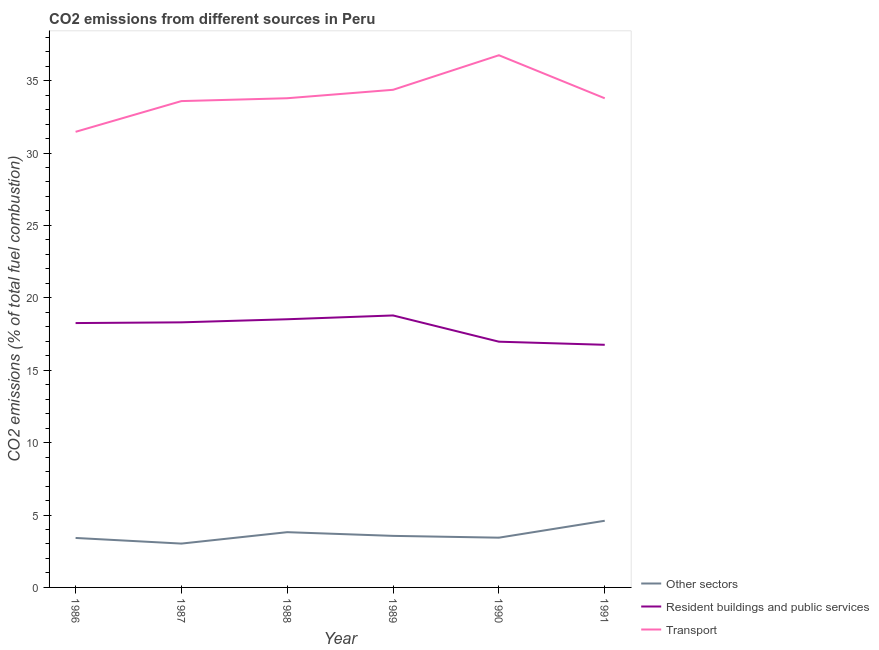Is the number of lines equal to the number of legend labels?
Give a very brief answer. Yes. What is the percentage of co2 emissions from other sectors in 1991?
Ensure brevity in your answer.  4.6. Across all years, what is the maximum percentage of co2 emissions from other sectors?
Offer a terse response. 4.6. Across all years, what is the minimum percentage of co2 emissions from transport?
Ensure brevity in your answer.  31.46. In which year was the percentage of co2 emissions from transport maximum?
Your answer should be compact. 1990. What is the total percentage of co2 emissions from other sectors in the graph?
Provide a short and direct response. 21.86. What is the difference between the percentage of co2 emissions from other sectors in 1989 and that in 1991?
Your response must be concise. -1.04. What is the difference between the percentage of co2 emissions from resident buildings and public services in 1989 and the percentage of co2 emissions from transport in 1991?
Provide a short and direct response. -15. What is the average percentage of co2 emissions from transport per year?
Offer a terse response. 33.95. In the year 1990, what is the difference between the percentage of co2 emissions from resident buildings and public services and percentage of co2 emissions from other sectors?
Give a very brief answer. 13.53. What is the ratio of the percentage of co2 emissions from transport in 1989 to that in 1990?
Keep it short and to the point. 0.94. What is the difference between the highest and the second highest percentage of co2 emissions from transport?
Ensure brevity in your answer.  2.39. What is the difference between the highest and the lowest percentage of co2 emissions from transport?
Your answer should be compact. 5.29. Is the sum of the percentage of co2 emissions from resident buildings and public services in 1988 and 1989 greater than the maximum percentage of co2 emissions from other sectors across all years?
Provide a succinct answer. Yes. Does the percentage of co2 emissions from other sectors monotonically increase over the years?
Make the answer very short. No. How many years are there in the graph?
Your answer should be very brief. 6. Are the values on the major ticks of Y-axis written in scientific E-notation?
Provide a succinct answer. No. Does the graph contain grids?
Provide a short and direct response. No. How many legend labels are there?
Make the answer very short. 3. What is the title of the graph?
Keep it short and to the point. CO2 emissions from different sources in Peru. Does "Coal sources" appear as one of the legend labels in the graph?
Keep it short and to the point. No. What is the label or title of the X-axis?
Give a very brief answer. Year. What is the label or title of the Y-axis?
Keep it short and to the point. CO2 emissions (% of total fuel combustion). What is the CO2 emissions (% of total fuel combustion) in Other sectors in 1986?
Provide a short and direct response. 3.42. What is the CO2 emissions (% of total fuel combustion) in Resident buildings and public services in 1986?
Your response must be concise. 18.26. What is the CO2 emissions (% of total fuel combustion) of Transport in 1986?
Offer a terse response. 31.46. What is the CO2 emissions (% of total fuel combustion) in Other sectors in 1987?
Keep it short and to the point. 3.03. What is the CO2 emissions (% of total fuel combustion) in Resident buildings and public services in 1987?
Ensure brevity in your answer.  18.31. What is the CO2 emissions (% of total fuel combustion) in Transport in 1987?
Your response must be concise. 33.59. What is the CO2 emissions (% of total fuel combustion) in Other sectors in 1988?
Your answer should be very brief. 3.82. What is the CO2 emissions (% of total fuel combustion) in Resident buildings and public services in 1988?
Offer a very short reply. 18.52. What is the CO2 emissions (% of total fuel combustion) of Transport in 1988?
Offer a very short reply. 33.78. What is the CO2 emissions (% of total fuel combustion) in Other sectors in 1989?
Keep it short and to the point. 3.56. What is the CO2 emissions (% of total fuel combustion) in Resident buildings and public services in 1989?
Your response must be concise. 18.78. What is the CO2 emissions (% of total fuel combustion) in Transport in 1989?
Ensure brevity in your answer.  34.37. What is the CO2 emissions (% of total fuel combustion) in Other sectors in 1990?
Provide a short and direct response. 3.44. What is the CO2 emissions (% of total fuel combustion) of Resident buildings and public services in 1990?
Your response must be concise. 16.97. What is the CO2 emissions (% of total fuel combustion) in Transport in 1990?
Give a very brief answer. 36.75. What is the CO2 emissions (% of total fuel combustion) of Other sectors in 1991?
Offer a terse response. 4.6. What is the CO2 emissions (% of total fuel combustion) of Resident buildings and public services in 1991?
Your answer should be very brief. 16.76. What is the CO2 emissions (% of total fuel combustion) of Transport in 1991?
Provide a short and direct response. 33.78. Across all years, what is the maximum CO2 emissions (% of total fuel combustion) in Other sectors?
Keep it short and to the point. 4.6. Across all years, what is the maximum CO2 emissions (% of total fuel combustion) in Resident buildings and public services?
Provide a succinct answer. 18.78. Across all years, what is the maximum CO2 emissions (% of total fuel combustion) in Transport?
Give a very brief answer. 36.75. Across all years, what is the minimum CO2 emissions (% of total fuel combustion) of Other sectors?
Give a very brief answer. 3.03. Across all years, what is the minimum CO2 emissions (% of total fuel combustion) in Resident buildings and public services?
Your answer should be very brief. 16.76. Across all years, what is the minimum CO2 emissions (% of total fuel combustion) in Transport?
Offer a very short reply. 31.46. What is the total CO2 emissions (% of total fuel combustion) of Other sectors in the graph?
Provide a short and direct response. 21.86. What is the total CO2 emissions (% of total fuel combustion) of Resident buildings and public services in the graph?
Your response must be concise. 107.59. What is the total CO2 emissions (% of total fuel combustion) of Transport in the graph?
Your answer should be compact. 203.73. What is the difference between the CO2 emissions (% of total fuel combustion) of Other sectors in 1986 and that in 1987?
Ensure brevity in your answer.  0.39. What is the difference between the CO2 emissions (% of total fuel combustion) of Resident buildings and public services in 1986 and that in 1987?
Keep it short and to the point. -0.05. What is the difference between the CO2 emissions (% of total fuel combustion) in Transport in 1986 and that in 1987?
Ensure brevity in your answer.  -2.12. What is the difference between the CO2 emissions (% of total fuel combustion) in Other sectors in 1986 and that in 1988?
Your response must be concise. -0.4. What is the difference between the CO2 emissions (% of total fuel combustion) of Resident buildings and public services in 1986 and that in 1988?
Offer a terse response. -0.26. What is the difference between the CO2 emissions (% of total fuel combustion) in Transport in 1986 and that in 1988?
Your answer should be very brief. -2.32. What is the difference between the CO2 emissions (% of total fuel combustion) of Other sectors in 1986 and that in 1989?
Provide a short and direct response. -0.14. What is the difference between the CO2 emissions (% of total fuel combustion) in Resident buildings and public services in 1986 and that in 1989?
Your response must be concise. -0.53. What is the difference between the CO2 emissions (% of total fuel combustion) of Transport in 1986 and that in 1989?
Provide a short and direct response. -2.9. What is the difference between the CO2 emissions (% of total fuel combustion) of Other sectors in 1986 and that in 1990?
Offer a terse response. -0.02. What is the difference between the CO2 emissions (% of total fuel combustion) of Resident buildings and public services in 1986 and that in 1990?
Your answer should be very brief. 1.29. What is the difference between the CO2 emissions (% of total fuel combustion) of Transport in 1986 and that in 1990?
Your answer should be very brief. -5.29. What is the difference between the CO2 emissions (% of total fuel combustion) of Other sectors in 1986 and that in 1991?
Give a very brief answer. -1.19. What is the difference between the CO2 emissions (% of total fuel combustion) in Resident buildings and public services in 1986 and that in 1991?
Your response must be concise. 1.5. What is the difference between the CO2 emissions (% of total fuel combustion) in Transport in 1986 and that in 1991?
Offer a very short reply. -2.32. What is the difference between the CO2 emissions (% of total fuel combustion) in Other sectors in 1987 and that in 1988?
Keep it short and to the point. -0.79. What is the difference between the CO2 emissions (% of total fuel combustion) in Resident buildings and public services in 1987 and that in 1988?
Your answer should be compact. -0.21. What is the difference between the CO2 emissions (% of total fuel combustion) of Transport in 1987 and that in 1988?
Give a very brief answer. -0.2. What is the difference between the CO2 emissions (% of total fuel combustion) in Other sectors in 1987 and that in 1989?
Offer a very short reply. -0.53. What is the difference between the CO2 emissions (% of total fuel combustion) of Resident buildings and public services in 1987 and that in 1989?
Provide a short and direct response. -0.48. What is the difference between the CO2 emissions (% of total fuel combustion) of Transport in 1987 and that in 1989?
Keep it short and to the point. -0.78. What is the difference between the CO2 emissions (% of total fuel combustion) of Other sectors in 1987 and that in 1990?
Give a very brief answer. -0.41. What is the difference between the CO2 emissions (% of total fuel combustion) of Resident buildings and public services in 1987 and that in 1990?
Your answer should be compact. 1.34. What is the difference between the CO2 emissions (% of total fuel combustion) of Transport in 1987 and that in 1990?
Your response must be concise. -3.17. What is the difference between the CO2 emissions (% of total fuel combustion) of Other sectors in 1987 and that in 1991?
Make the answer very short. -1.58. What is the difference between the CO2 emissions (% of total fuel combustion) of Resident buildings and public services in 1987 and that in 1991?
Your answer should be compact. 1.55. What is the difference between the CO2 emissions (% of total fuel combustion) in Transport in 1987 and that in 1991?
Your answer should be very brief. -0.19. What is the difference between the CO2 emissions (% of total fuel combustion) of Other sectors in 1988 and that in 1989?
Your response must be concise. 0.26. What is the difference between the CO2 emissions (% of total fuel combustion) in Resident buildings and public services in 1988 and that in 1989?
Keep it short and to the point. -0.26. What is the difference between the CO2 emissions (% of total fuel combustion) of Transport in 1988 and that in 1989?
Give a very brief answer. -0.58. What is the difference between the CO2 emissions (% of total fuel combustion) of Other sectors in 1988 and that in 1990?
Provide a short and direct response. 0.38. What is the difference between the CO2 emissions (% of total fuel combustion) in Resident buildings and public services in 1988 and that in 1990?
Your response must be concise. 1.55. What is the difference between the CO2 emissions (% of total fuel combustion) in Transport in 1988 and that in 1990?
Your answer should be very brief. -2.97. What is the difference between the CO2 emissions (% of total fuel combustion) in Other sectors in 1988 and that in 1991?
Your answer should be compact. -0.79. What is the difference between the CO2 emissions (% of total fuel combustion) in Resident buildings and public services in 1988 and that in 1991?
Your response must be concise. 1.76. What is the difference between the CO2 emissions (% of total fuel combustion) in Transport in 1988 and that in 1991?
Your answer should be very brief. 0. What is the difference between the CO2 emissions (% of total fuel combustion) in Other sectors in 1989 and that in 1990?
Your response must be concise. 0.12. What is the difference between the CO2 emissions (% of total fuel combustion) of Resident buildings and public services in 1989 and that in 1990?
Give a very brief answer. 1.81. What is the difference between the CO2 emissions (% of total fuel combustion) in Transport in 1989 and that in 1990?
Offer a terse response. -2.39. What is the difference between the CO2 emissions (% of total fuel combustion) of Other sectors in 1989 and that in 1991?
Keep it short and to the point. -1.04. What is the difference between the CO2 emissions (% of total fuel combustion) in Resident buildings and public services in 1989 and that in 1991?
Offer a terse response. 2.03. What is the difference between the CO2 emissions (% of total fuel combustion) in Transport in 1989 and that in 1991?
Your response must be concise. 0.59. What is the difference between the CO2 emissions (% of total fuel combustion) of Other sectors in 1990 and that in 1991?
Offer a very short reply. -1.17. What is the difference between the CO2 emissions (% of total fuel combustion) in Resident buildings and public services in 1990 and that in 1991?
Give a very brief answer. 0.21. What is the difference between the CO2 emissions (% of total fuel combustion) of Transport in 1990 and that in 1991?
Your response must be concise. 2.97. What is the difference between the CO2 emissions (% of total fuel combustion) in Other sectors in 1986 and the CO2 emissions (% of total fuel combustion) in Resident buildings and public services in 1987?
Ensure brevity in your answer.  -14.89. What is the difference between the CO2 emissions (% of total fuel combustion) of Other sectors in 1986 and the CO2 emissions (% of total fuel combustion) of Transport in 1987?
Provide a succinct answer. -30.17. What is the difference between the CO2 emissions (% of total fuel combustion) of Resident buildings and public services in 1986 and the CO2 emissions (% of total fuel combustion) of Transport in 1987?
Your response must be concise. -15.33. What is the difference between the CO2 emissions (% of total fuel combustion) in Other sectors in 1986 and the CO2 emissions (% of total fuel combustion) in Resident buildings and public services in 1988?
Make the answer very short. -15.1. What is the difference between the CO2 emissions (% of total fuel combustion) of Other sectors in 1986 and the CO2 emissions (% of total fuel combustion) of Transport in 1988?
Provide a succinct answer. -30.37. What is the difference between the CO2 emissions (% of total fuel combustion) in Resident buildings and public services in 1986 and the CO2 emissions (% of total fuel combustion) in Transport in 1988?
Give a very brief answer. -15.53. What is the difference between the CO2 emissions (% of total fuel combustion) in Other sectors in 1986 and the CO2 emissions (% of total fuel combustion) in Resident buildings and public services in 1989?
Provide a succinct answer. -15.37. What is the difference between the CO2 emissions (% of total fuel combustion) in Other sectors in 1986 and the CO2 emissions (% of total fuel combustion) in Transport in 1989?
Provide a succinct answer. -30.95. What is the difference between the CO2 emissions (% of total fuel combustion) in Resident buildings and public services in 1986 and the CO2 emissions (% of total fuel combustion) in Transport in 1989?
Your answer should be very brief. -16.11. What is the difference between the CO2 emissions (% of total fuel combustion) in Other sectors in 1986 and the CO2 emissions (% of total fuel combustion) in Resident buildings and public services in 1990?
Your response must be concise. -13.55. What is the difference between the CO2 emissions (% of total fuel combustion) of Other sectors in 1986 and the CO2 emissions (% of total fuel combustion) of Transport in 1990?
Your answer should be very brief. -33.34. What is the difference between the CO2 emissions (% of total fuel combustion) in Resident buildings and public services in 1986 and the CO2 emissions (% of total fuel combustion) in Transport in 1990?
Keep it short and to the point. -18.5. What is the difference between the CO2 emissions (% of total fuel combustion) of Other sectors in 1986 and the CO2 emissions (% of total fuel combustion) of Resident buildings and public services in 1991?
Provide a short and direct response. -13.34. What is the difference between the CO2 emissions (% of total fuel combustion) of Other sectors in 1986 and the CO2 emissions (% of total fuel combustion) of Transport in 1991?
Your answer should be very brief. -30.36. What is the difference between the CO2 emissions (% of total fuel combustion) in Resident buildings and public services in 1986 and the CO2 emissions (% of total fuel combustion) in Transport in 1991?
Offer a terse response. -15.52. What is the difference between the CO2 emissions (% of total fuel combustion) in Other sectors in 1987 and the CO2 emissions (% of total fuel combustion) in Resident buildings and public services in 1988?
Give a very brief answer. -15.49. What is the difference between the CO2 emissions (% of total fuel combustion) of Other sectors in 1987 and the CO2 emissions (% of total fuel combustion) of Transport in 1988?
Provide a short and direct response. -30.76. What is the difference between the CO2 emissions (% of total fuel combustion) in Resident buildings and public services in 1987 and the CO2 emissions (% of total fuel combustion) in Transport in 1988?
Ensure brevity in your answer.  -15.48. What is the difference between the CO2 emissions (% of total fuel combustion) of Other sectors in 1987 and the CO2 emissions (% of total fuel combustion) of Resident buildings and public services in 1989?
Your response must be concise. -15.75. What is the difference between the CO2 emissions (% of total fuel combustion) in Other sectors in 1987 and the CO2 emissions (% of total fuel combustion) in Transport in 1989?
Keep it short and to the point. -31.34. What is the difference between the CO2 emissions (% of total fuel combustion) of Resident buildings and public services in 1987 and the CO2 emissions (% of total fuel combustion) of Transport in 1989?
Offer a terse response. -16.06. What is the difference between the CO2 emissions (% of total fuel combustion) in Other sectors in 1987 and the CO2 emissions (% of total fuel combustion) in Resident buildings and public services in 1990?
Offer a very short reply. -13.94. What is the difference between the CO2 emissions (% of total fuel combustion) in Other sectors in 1987 and the CO2 emissions (% of total fuel combustion) in Transport in 1990?
Keep it short and to the point. -33.72. What is the difference between the CO2 emissions (% of total fuel combustion) of Resident buildings and public services in 1987 and the CO2 emissions (% of total fuel combustion) of Transport in 1990?
Your answer should be very brief. -18.45. What is the difference between the CO2 emissions (% of total fuel combustion) in Other sectors in 1987 and the CO2 emissions (% of total fuel combustion) in Resident buildings and public services in 1991?
Offer a terse response. -13.73. What is the difference between the CO2 emissions (% of total fuel combustion) in Other sectors in 1987 and the CO2 emissions (% of total fuel combustion) in Transport in 1991?
Your answer should be very brief. -30.75. What is the difference between the CO2 emissions (% of total fuel combustion) in Resident buildings and public services in 1987 and the CO2 emissions (% of total fuel combustion) in Transport in 1991?
Offer a terse response. -15.47. What is the difference between the CO2 emissions (% of total fuel combustion) of Other sectors in 1988 and the CO2 emissions (% of total fuel combustion) of Resident buildings and public services in 1989?
Provide a succinct answer. -14.97. What is the difference between the CO2 emissions (% of total fuel combustion) of Other sectors in 1988 and the CO2 emissions (% of total fuel combustion) of Transport in 1989?
Give a very brief answer. -30.55. What is the difference between the CO2 emissions (% of total fuel combustion) in Resident buildings and public services in 1988 and the CO2 emissions (% of total fuel combustion) in Transport in 1989?
Your response must be concise. -15.85. What is the difference between the CO2 emissions (% of total fuel combustion) of Other sectors in 1988 and the CO2 emissions (% of total fuel combustion) of Resident buildings and public services in 1990?
Provide a short and direct response. -13.15. What is the difference between the CO2 emissions (% of total fuel combustion) in Other sectors in 1988 and the CO2 emissions (% of total fuel combustion) in Transport in 1990?
Offer a terse response. -32.94. What is the difference between the CO2 emissions (% of total fuel combustion) in Resident buildings and public services in 1988 and the CO2 emissions (% of total fuel combustion) in Transport in 1990?
Offer a terse response. -18.23. What is the difference between the CO2 emissions (% of total fuel combustion) of Other sectors in 1988 and the CO2 emissions (% of total fuel combustion) of Resident buildings and public services in 1991?
Make the answer very short. -12.94. What is the difference between the CO2 emissions (% of total fuel combustion) in Other sectors in 1988 and the CO2 emissions (% of total fuel combustion) in Transport in 1991?
Offer a very short reply. -29.96. What is the difference between the CO2 emissions (% of total fuel combustion) of Resident buildings and public services in 1988 and the CO2 emissions (% of total fuel combustion) of Transport in 1991?
Ensure brevity in your answer.  -15.26. What is the difference between the CO2 emissions (% of total fuel combustion) in Other sectors in 1989 and the CO2 emissions (% of total fuel combustion) in Resident buildings and public services in 1990?
Provide a short and direct response. -13.41. What is the difference between the CO2 emissions (% of total fuel combustion) in Other sectors in 1989 and the CO2 emissions (% of total fuel combustion) in Transport in 1990?
Provide a succinct answer. -33.19. What is the difference between the CO2 emissions (% of total fuel combustion) of Resident buildings and public services in 1989 and the CO2 emissions (% of total fuel combustion) of Transport in 1990?
Ensure brevity in your answer.  -17.97. What is the difference between the CO2 emissions (% of total fuel combustion) of Other sectors in 1989 and the CO2 emissions (% of total fuel combustion) of Resident buildings and public services in 1991?
Make the answer very short. -13.2. What is the difference between the CO2 emissions (% of total fuel combustion) of Other sectors in 1989 and the CO2 emissions (% of total fuel combustion) of Transport in 1991?
Your answer should be very brief. -30.22. What is the difference between the CO2 emissions (% of total fuel combustion) in Resident buildings and public services in 1989 and the CO2 emissions (% of total fuel combustion) in Transport in 1991?
Give a very brief answer. -15. What is the difference between the CO2 emissions (% of total fuel combustion) of Other sectors in 1990 and the CO2 emissions (% of total fuel combustion) of Resident buildings and public services in 1991?
Keep it short and to the point. -13.32. What is the difference between the CO2 emissions (% of total fuel combustion) of Other sectors in 1990 and the CO2 emissions (% of total fuel combustion) of Transport in 1991?
Make the answer very short. -30.34. What is the difference between the CO2 emissions (% of total fuel combustion) in Resident buildings and public services in 1990 and the CO2 emissions (% of total fuel combustion) in Transport in 1991?
Provide a succinct answer. -16.81. What is the average CO2 emissions (% of total fuel combustion) in Other sectors per year?
Ensure brevity in your answer.  3.64. What is the average CO2 emissions (% of total fuel combustion) of Resident buildings and public services per year?
Make the answer very short. 17.93. What is the average CO2 emissions (% of total fuel combustion) in Transport per year?
Ensure brevity in your answer.  33.95. In the year 1986, what is the difference between the CO2 emissions (% of total fuel combustion) in Other sectors and CO2 emissions (% of total fuel combustion) in Resident buildings and public services?
Keep it short and to the point. -14.84. In the year 1986, what is the difference between the CO2 emissions (% of total fuel combustion) of Other sectors and CO2 emissions (% of total fuel combustion) of Transport?
Offer a terse response. -28.05. In the year 1986, what is the difference between the CO2 emissions (% of total fuel combustion) in Resident buildings and public services and CO2 emissions (% of total fuel combustion) in Transport?
Offer a terse response. -13.21. In the year 1987, what is the difference between the CO2 emissions (% of total fuel combustion) of Other sectors and CO2 emissions (% of total fuel combustion) of Resident buildings and public services?
Provide a succinct answer. -15.28. In the year 1987, what is the difference between the CO2 emissions (% of total fuel combustion) of Other sectors and CO2 emissions (% of total fuel combustion) of Transport?
Make the answer very short. -30.56. In the year 1987, what is the difference between the CO2 emissions (% of total fuel combustion) in Resident buildings and public services and CO2 emissions (% of total fuel combustion) in Transport?
Your response must be concise. -15.28. In the year 1988, what is the difference between the CO2 emissions (% of total fuel combustion) in Other sectors and CO2 emissions (% of total fuel combustion) in Resident buildings and public services?
Provide a succinct answer. -14.7. In the year 1988, what is the difference between the CO2 emissions (% of total fuel combustion) of Other sectors and CO2 emissions (% of total fuel combustion) of Transport?
Make the answer very short. -29.97. In the year 1988, what is the difference between the CO2 emissions (% of total fuel combustion) of Resident buildings and public services and CO2 emissions (% of total fuel combustion) of Transport?
Ensure brevity in your answer.  -15.26. In the year 1989, what is the difference between the CO2 emissions (% of total fuel combustion) in Other sectors and CO2 emissions (% of total fuel combustion) in Resident buildings and public services?
Your answer should be very brief. -15.22. In the year 1989, what is the difference between the CO2 emissions (% of total fuel combustion) in Other sectors and CO2 emissions (% of total fuel combustion) in Transport?
Give a very brief answer. -30.8. In the year 1989, what is the difference between the CO2 emissions (% of total fuel combustion) in Resident buildings and public services and CO2 emissions (% of total fuel combustion) in Transport?
Give a very brief answer. -15.58. In the year 1990, what is the difference between the CO2 emissions (% of total fuel combustion) of Other sectors and CO2 emissions (% of total fuel combustion) of Resident buildings and public services?
Provide a short and direct response. -13.53. In the year 1990, what is the difference between the CO2 emissions (% of total fuel combustion) in Other sectors and CO2 emissions (% of total fuel combustion) in Transport?
Your answer should be compact. -33.32. In the year 1990, what is the difference between the CO2 emissions (% of total fuel combustion) of Resident buildings and public services and CO2 emissions (% of total fuel combustion) of Transport?
Offer a terse response. -19.78. In the year 1991, what is the difference between the CO2 emissions (% of total fuel combustion) in Other sectors and CO2 emissions (% of total fuel combustion) in Resident buildings and public services?
Keep it short and to the point. -12.15. In the year 1991, what is the difference between the CO2 emissions (% of total fuel combustion) of Other sectors and CO2 emissions (% of total fuel combustion) of Transport?
Offer a very short reply. -29.18. In the year 1991, what is the difference between the CO2 emissions (% of total fuel combustion) in Resident buildings and public services and CO2 emissions (% of total fuel combustion) in Transport?
Your answer should be compact. -17.02. What is the ratio of the CO2 emissions (% of total fuel combustion) of Other sectors in 1986 to that in 1987?
Provide a short and direct response. 1.13. What is the ratio of the CO2 emissions (% of total fuel combustion) of Resident buildings and public services in 1986 to that in 1987?
Provide a succinct answer. 1. What is the ratio of the CO2 emissions (% of total fuel combustion) of Transport in 1986 to that in 1987?
Provide a short and direct response. 0.94. What is the ratio of the CO2 emissions (% of total fuel combustion) in Other sectors in 1986 to that in 1988?
Offer a terse response. 0.9. What is the ratio of the CO2 emissions (% of total fuel combustion) in Resident buildings and public services in 1986 to that in 1988?
Make the answer very short. 0.99. What is the ratio of the CO2 emissions (% of total fuel combustion) of Transport in 1986 to that in 1988?
Offer a terse response. 0.93. What is the ratio of the CO2 emissions (% of total fuel combustion) of Other sectors in 1986 to that in 1989?
Provide a short and direct response. 0.96. What is the ratio of the CO2 emissions (% of total fuel combustion) of Resident buildings and public services in 1986 to that in 1989?
Ensure brevity in your answer.  0.97. What is the ratio of the CO2 emissions (% of total fuel combustion) in Transport in 1986 to that in 1989?
Provide a short and direct response. 0.92. What is the ratio of the CO2 emissions (% of total fuel combustion) of Other sectors in 1986 to that in 1990?
Provide a short and direct response. 0.99. What is the ratio of the CO2 emissions (% of total fuel combustion) in Resident buildings and public services in 1986 to that in 1990?
Make the answer very short. 1.08. What is the ratio of the CO2 emissions (% of total fuel combustion) of Transport in 1986 to that in 1990?
Your response must be concise. 0.86. What is the ratio of the CO2 emissions (% of total fuel combustion) of Other sectors in 1986 to that in 1991?
Make the answer very short. 0.74. What is the ratio of the CO2 emissions (% of total fuel combustion) in Resident buildings and public services in 1986 to that in 1991?
Offer a terse response. 1.09. What is the ratio of the CO2 emissions (% of total fuel combustion) of Transport in 1986 to that in 1991?
Provide a succinct answer. 0.93. What is the ratio of the CO2 emissions (% of total fuel combustion) of Other sectors in 1987 to that in 1988?
Provide a short and direct response. 0.79. What is the ratio of the CO2 emissions (% of total fuel combustion) of Resident buildings and public services in 1987 to that in 1988?
Ensure brevity in your answer.  0.99. What is the ratio of the CO2 emissions (% of total fuel combustion) of Other sectors in 1987 to that in 1989?
Offer a very short reply. 0.85. What is the ratio of the CO2 emissions (% of total fuel combustion) of Resident buildings and public services in 1987 to that in 1989?
Provide a short and direct response. 0.97. What is the ratio of the CO2 emissions (% of total fuel combustion) in Transport in 1987 to that in 1989?
Provide a short and direct response. 0.98. What is the ratio of the CO2 emissions (% of total fuel combustion) of Other sectors in 1987 to that in 1990?
Ensure brevity in your answer.  0.88. What is the ratio of the CO2 emissions (% of total fuel combustion) of Resident buildings and public services in 1987 to that in 1990?
Give a very brief answer. 1.08. What is the ratio of the CO2 emissions (% of total fuel combustion) in Transport in 1987 to that in 1990?
Your answer should be very brief. 0.91. What is the ratio of the CO2 emissions (% of total fuel combustion) in Other sectors in 1987 to that in 1991?
Provide a short and direct response. 0.66. What is the ratio of the CO2 emissions (% of total fuel combustion) in Resident buildings and public services in 1987 to that in 1991?
Make the answer very short. 1.09. What is the ratio of the CO2 emissions (% of total fuel combustion) in Other sectors in 1988 to that in 1989?
Ensure brevity in your answer.  1.07. What is the ratio of the CO2 emissions (% of total fuel combustion) in Resident buildings and public services in 1988 to that in 1989?
Offer a terse response. 0.99. What is the ratio of the CO2 emissions (% of total fuel combustion) of Transport in 1988 to that in 1989?
Ensure brevity in your answer.  0.98. What is the ratio of the CO2 emissions (% of total fuel combustion) of Other sectors in 1988 to that in 1990?
Provide a short and direct response. 1.11. What is the ratio of the CO2 emissions (% of total fuel combustion) in Resident buildings and public services in 1988 to that in 1990?
Keep it short and to the point. 1.09. What is the ratio of the CO2 emissions (% of total fuel combustion) of Transport in 1988 to that in 1990?
Keep it short and to the point. 0.92. What is the ratio of the CO2 emissions (% of total fuel combustion) of Other sectors in 1988 to that in 1991?
Your response must be concise. 0.83. What is the ratio of the CO2 emissions (% of total fuel combustion) of Resident buildings and public services in 1988 to that in 1991?
Your answer should be very brief. 1.11. What is the ratio of the CO2 emissions (% of total fuel combustion) in Transport in 1988 to that in 1991?
Your answer should be very brief. 1. What is the ratio of the CO2 emissions (% of total fuel combustion) of Other sectors in 1989 to that in 1990?
Keep it short and to the point. 1.04. What is the ratio of the CO2 emissions (% of total fuel combustion) in Resident buildings and public services in 1989 to that in 1990?
Your answer should be compact. 1.11. What is the ratio of the CO2 emissions (% of total fuel combustion) of Transport in 1989 to that in 1990?
Keep it short and to the point. 0.94. What is the ratio of the CO2 emissions (% of total fuel combustion) in Other sectors in 1989 to that in 1991?
Offer a terse response. 0.77. What is the ratio of the CO2 emissions (% of total fuel combustion) of Resident buildings and public services in 1989 to that in 1991?
Your response must be concise. 1.12. What is the ratio of the CO2 emissions (% of total fuel combustion) in Transport in 1989 to that in 1991?
Your response must be concise. 1.02. What is the ratio of the CO2 emissions (% of total fuel combustion) of Other sectors in 1990 to that in 1991?
Your answer should be very brief. 0.75. What is the ratio of the CO2 emissions (% of total fuel combustion) of Resident buildings and public services in 1990 to that in 1991?
Offer a very short reply. 1.01. What is the ratio of the CO2 emissions (% of total fuel combustion) in Transport in 1990 to that in 1991?
Your response must be concise. 1.09. What is the difference between the highest and the second highest CO2 emissions (% of total fuel combustion) in Other sectors?
Ensure brevity in your answer.  0.79. What is the difference between the highest and the second highest CO2 emissions (% of total fuel combustion) of Resident buildings and public services?
Offer a very short reply. 0.26. What is the difference between the highest and the second highest CO2 emissions (% of total fuel combustion) in Transport?
Offer a very short reply. 2.39. What is the difference between the highest and the lowest CO2 emissions (% of total fuel combustion) of Other sectors?
Your response must be concise. 1.58. What is the difference between the highest and the lowest CO2 emissions (% of total fuel combustion) of Resident buildings and public services?
Offer a very short reply. 2.03. What is the difference between the highest and the lowest CO2 emissions (% of total fuel combustion) in Transport?
Offer a very short reply. 5.29. 